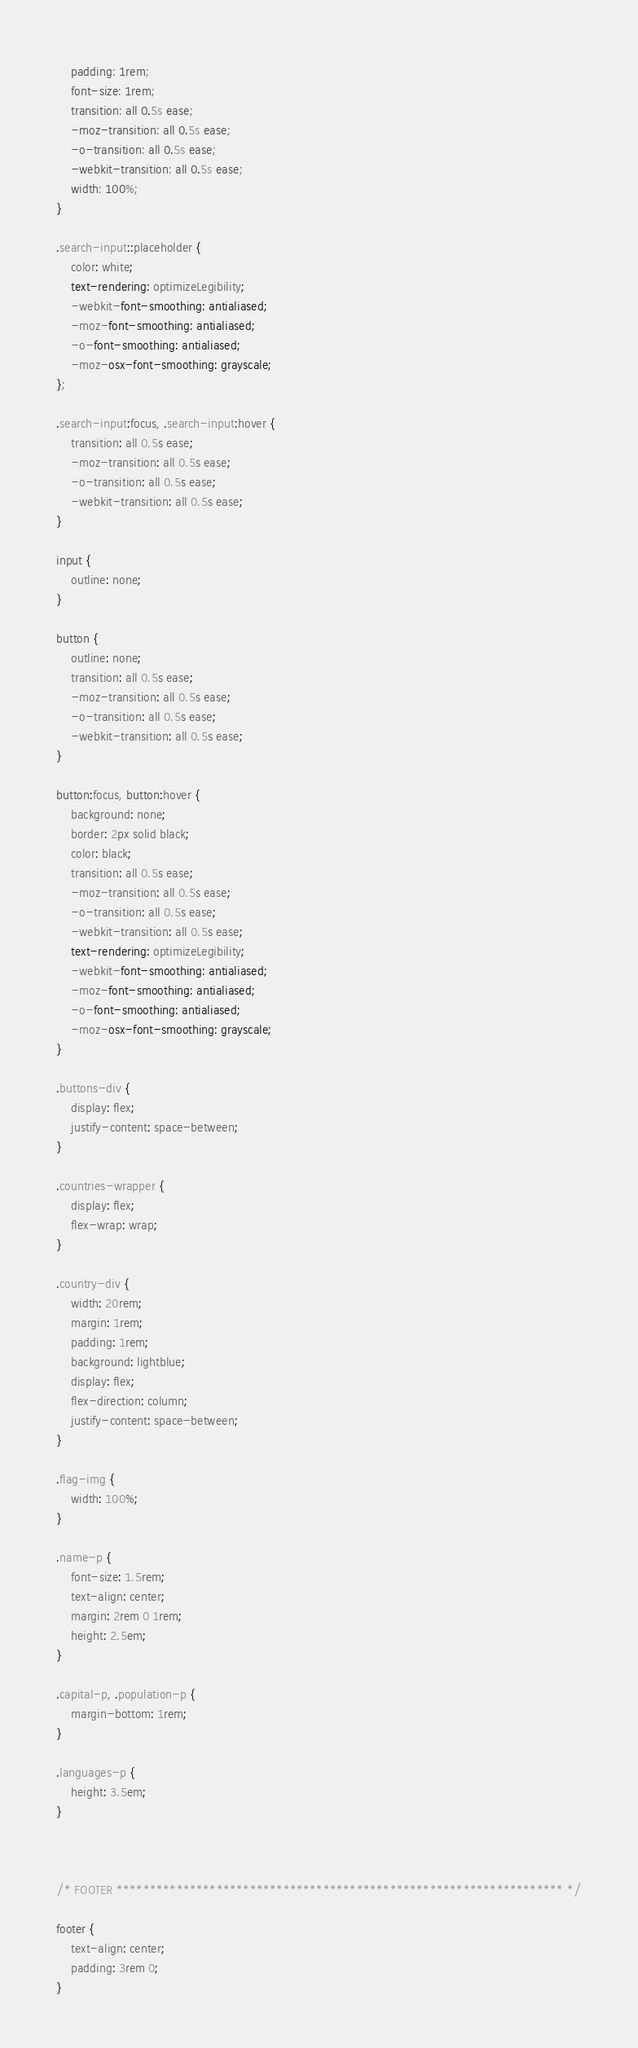Convert code to text. <code><loc_0><loc_0><loc_500><loc_500><_CSS_>    padding: 1rem;
    font-size: 1rem;
    transition: all 0.5s ease;
    -moz-transition: all 0.5s ease;
    -o-transition: all 0.5s ease;
    -webkit-transition: all 0.5s ease;
    width: 100%;
}

.search-input::placeholder {
    color: white;
    text-rendering: optimizeLegibility;
    -webkit-font-smoothing: antialiased;
    -moz-font-smoothing: antialiased;
    -o-font-smoothing: antialiased;
    -moz-osx-font-smoothing: grayscale;
};

.search-input:focus, .search-input:hover {
    transition: all 0.5s ease;
    -moz-transition: all 0.5s ease;
    -o-transition: all 0.5s ease;
    -webkit-transition: all 0.5s ease;
}

input {
    outline: none;
}

button {
    outline: none;
    transition: all 0.5s ease;
    -moz-transition: all 0.5s ease;
    -o-transition: all 0.5s ease;
    -webkit-transition: all 0.5s ease;
}

button:focus, button:hover {
    background: none;
    border: 2px solid black;
    color: black;
    transition: all 0.5s ease;
    -moz-transition: all 0.5s ease;
    -o-transition: all 0.5s ease;
    -webkit-transition: all 0.5s ease;
    text-rendering: optimizeLegibility;
    -webkit-font-smoothing: antialiased;
    -moz-font-smoothing: antialiased;
    -o-font-smoothing: antialiased;
    -moz-osx-font-smoothing: grayscale;
}

.buttons-div {
    display: flex;
    justify-content: space-between;
}

.countries-wrapper {
    display: flex;
    flex-wrap: wrap;
}

.country-div {
    width: 20rem;
    margin: 1rem;
    padding: 1rem;
    background: lightblue;
    display: flex;
    flex-direction: column;
    justify-content: space-between;
}

.flag-img {
    width: 100%;
}

.name-p {
    font-size: 1.5rem;
    text-align: center;
    margin: 2rem 0 1rem;
    height: 2.5em;
}

.capital-p, .population-p {
    margin-bottom: 1rem;
}

.languages-p {
    height: 3.5em;
}



/* FOOTER ******************************************************************* */

footer {
    text-align: center;
    padding: 3rem 0;
}

</code> 